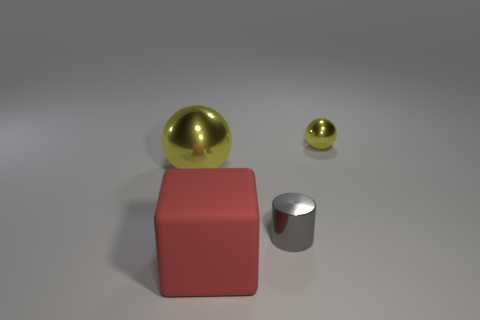What is the color of the other thing that is the same size as the rubber thing?
Provide a succinct answer. Yellow. How many spheres are either tiny things or yellow metallic things?
Offer a very short reply. 2. Does the matte thing have the same shape as the yellow metallic thing that is to the left of the big matte block?
Keep it short and to the point. No. What number of shiny spheres are the same size as the cube?
Offer a very short reply. 1. There is a yellow thing that is on the right side of the rubber thing; does it have the same shape as the yellow object that is on the left side of the small sphere?
Keep it short and to the point. Yes. What shape is the small object that is the same color as the large shiny object?
Offer a terse response. Sphere. What color is the small thing that is behind the small object that is in front of the tiny yellow sphere?
Make the answer very short. Yellow. What color is the tiny metallic object that is the same shape as the large yellow metallic thing?
Offer a terse response. Yellow. Is there anything else that has the same material as the small gray thing?
Give a very brief answer. Yes. The other yellow thing that is the same shape as the large yellow metal object is what size?
Keep it short and to the point. Small. 